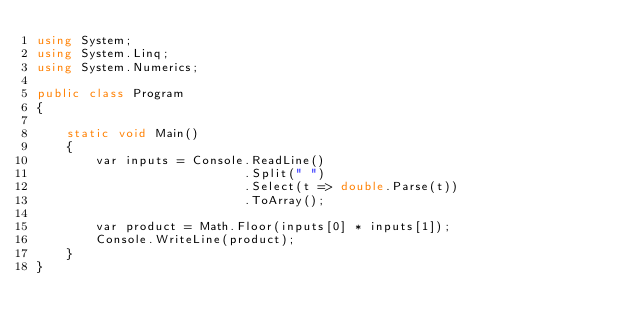<code> <loc_0><loc_0><loc_500><loc_500><_C#_>using System;
using System.Linq;
using System.Numerics;

public class Program
{

    static void Main()
    {
        var inputs = Console.ReadLine()
                            .Split(" ")
                            .Select(t => double.Parse(t))
                            .ToArray();

        var product = Math.Floor(inputs[0] * inputs[1]);
        Console.WriteLine(product); 
    }
}
</code> 